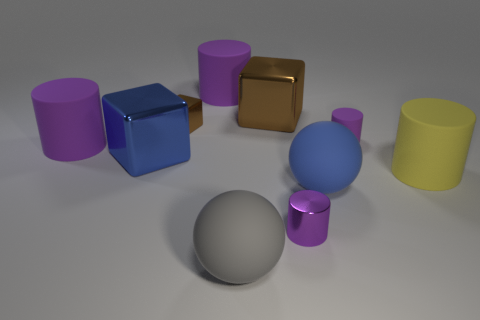What mood or atmosphere does the composition of the image evoke? The composition of the image, with its clean lines, smooth surfaces, and muted pastel colors against a neutral background, evokes a feeling of calm and order. The simplicity and balance within the arrangement lend a minimalist and modern aesthetic to the scene. It could be reflective of a controlled environment, perhaps indicative of a design space or a conceptual art piece meant to focus on form and color. 